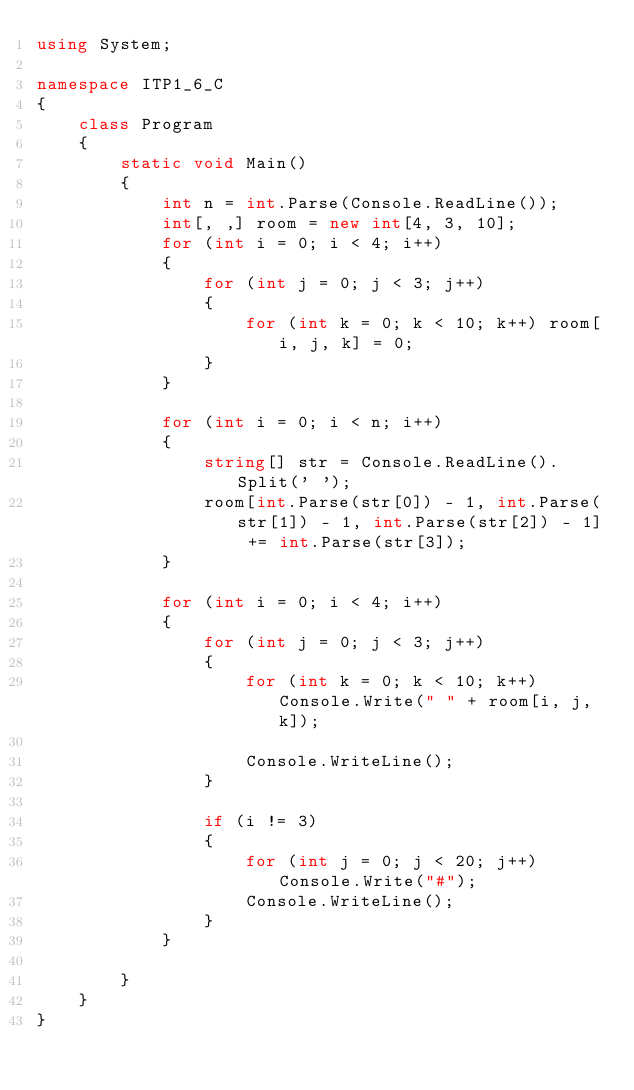Convert code to text. <code><loc_0><loc_0><loc_500><loc_500><_C#_>using System;

namespace ITP1_6_C
{
    class Program
    {
        static void Main()
        {
            int n = int.Parse(Console.ReadLine());
            int[, ,] room = new int[4, 3, 10];
            for (int i = 0; i < 4; i++)
            {
                for (int j = 0; j < 3; j++)
                {
                    for (int k = 0; k < 10; k++) room[i, j, k] = 0;
                }
            }

            for (int i = 0; i < n; i++)
            {
                string[] str = Console.ReadLine().Split(' ');
                room[int.Parse(str[0]) - 1, int.Parse(str[1]) - 1, int.Parse(str[2]) - 1] += int.Parse(str[3]);
            }

            for (int i = 0; i < 4; i++)
            {
                for (int j = 0; j < 3; j++)
                {
                    for (int k = 0; k < 10; k++) Console.Write(" " + room[i, j, k]);

                    Console.WriteLine();
                }

                if (i != 3)
                {
                    for (int j = 0; j < 20; j++) Console.Write("#");
                    Console.WriteLine();
                }
            }

        }
    }
}</code> 